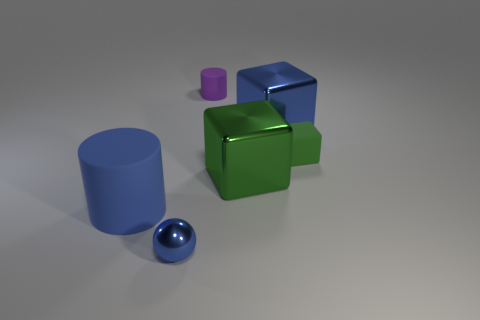Subtract all blue metallic blocks. How many blocks are left? 2 Add 1 small gray rubber cylinders. How many objects exist? 7 Subtract all spheres. How many objects are left? 5 Add 1 big metal blocks. How many big metal blocks exist? 3 Subtract 0 red spheres. How many objects are left? 6 Subtract all big green objects. Subtract all blue balls. How many objects are left? 4 Add 2 big green metallic objects. How many big green metallic objects are left? 3 